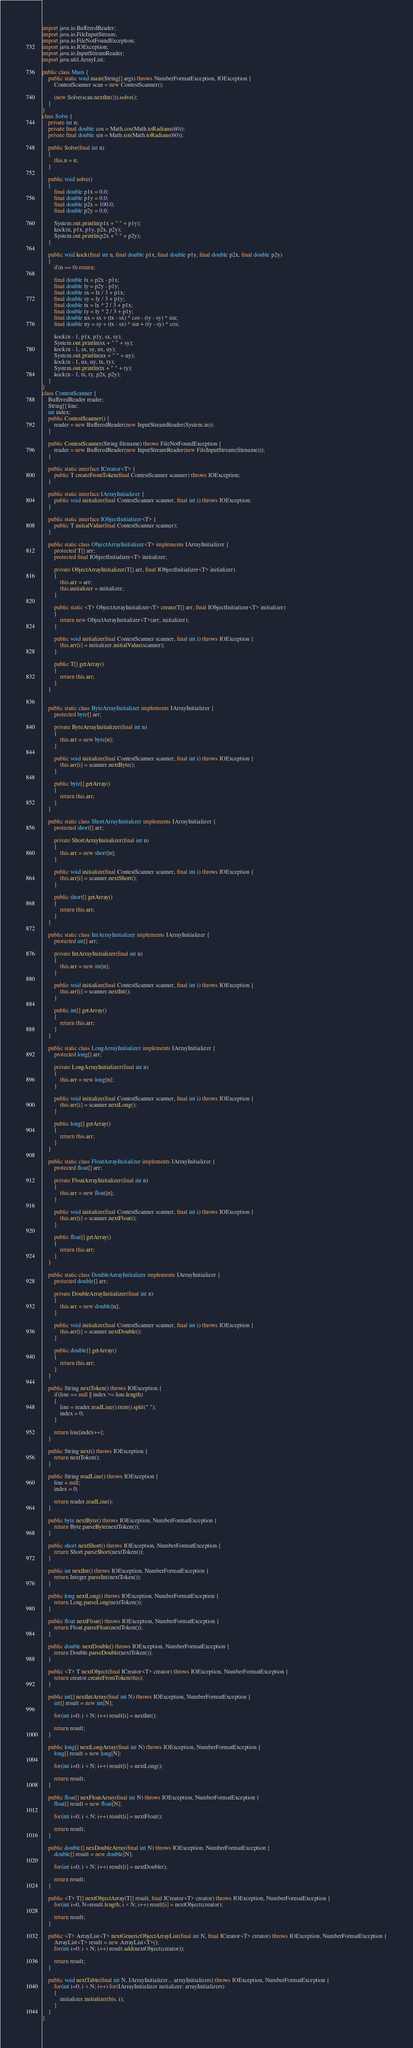Convert code to text. <code><loc_0><loc_0><loc_500><loc_500><_Java_>import java.io.BufferedReader;
import java.io.FileInputStream;
import java.io.FileNotFoundException;
import java.io.IOException;
import java.io.InputStreamReader;
import java.util.ArrayList;

public class Main {
	public static void main(String[] args) throws NumberFormatException, IOException {
		ContestScanner scan = new ContestScanner();

		(new Solve(scan.nextInt())).solve();
	}
}
class Solve {
	private int n;
	private final double cos = Math.cos(Math.toRadians(60));
	private final double sin = Math.sin(Math.toRadians(60));

	public Solve(final int n)
	{
		this.n = n;
	}

	public void solve()
	{
		final double p1x = 0.0;
		final double p1y = 0.0;
		final double p2x = 100.0;
		final double p2y = 0.0;

		System.out.println(p1x + " " + p1y);
		kock(n, p1x, p1y, p2x, p2y);
		System.out.println(p2x + " " + p2y);
	}

	public void kock(final int n, final double p1x, final double p1y, final double p2x, final double p2y)
	{
		if(n == 0) return;

		final double lx = p2x - p1x;
		final double ly = p2y - p1y;
		final double sx = lx / 3 + p1x;
		final double sy = ly / 3 + p1y;
		final double tx = lx * 2 / 3 + p1x;
		final double ty = ly * 2 / 3 + p1y;
		final double ux = sx + (tx - sx) * cos - (ty - sy) * sin;
		final double uy = sy + (tx - sx) * sin + (ty - sy) * cos;

		kock(n - 1, p1x, p1y, sx, sy);
		System.out.println(sx + " " + sy);
		kock(n - 1, sx, sy, ux, uy);
		System.out.println(ux + " " + uy);
		kock(n - 1, ux, uy, tx, ty);
		System.out.println(tx + " " + ty);
		kock(n - 1, tx, ty, p2x, p2y);
	}
}
class ContestScanner {
	BufferedReader reader;
	String[] line;
	int index;
	public ContestScanner() {
		reader = new BufferedReader(new InputStreamReader(System.in));
	}

	public ContestScanner(String filename) throws FileNotFoundException {
		reader = new BufferedReader(new InputStreamReader(new FileInputStream(filename)));
	}

	public static interface ICreator<T> {
		public T createFromToken(final ContestScanner scanner) throws IOException;
	}

	public static interface IArrayInitializer {
		public void initialize(final ContestScanner scanner, final int i) throws IOException;
	}

	public static interface IObjectInitializer<T> {
		public T initialValue(final ContestScanner scanner);
	}

	public static class ObjectArrayInitializer<T> implements IArrayInitializer {
		protected T[] arr;
		protected final IObjectInitializer<T> initializer;

		private ObjectArrayInitializer(T[] arr, final IObjectInitializer<T> initializer)
		{
			this.arr = arr;
			this.initializer = initializer;
		}

		public static <T> ObjectArrayInitializer<T> create(T[] arr, final IObjectInitializer<T> initializer)
		{
			return new ObjectArrayInitializer<T>(arr, initializer);
		}

		public void initialize(final ContestScanner scanner, final int i) throws IOException {
			this.arr[i] = initializer.initialValue(scanner);
		}

		public T[] getArray()
		{
			return this.arr;
		}
	}


	public static class ByteArrayInitializer implements IArrayInitializer {
		protected byte[] arr;

		private ByteArrayInitializer(final int n)
		{
			this.arr = new byte[n];
		}

		public void initialize(final ContestScanner scanner, final int i) throws IOException {
			this.arr[i] = scanner.nextByte();
		}

		public byte[] getArray()
		{
			return this.arr;
		}
	}

	public static class ShortArrayInitializer implements IArrayInitializer {
		protected short[] arr;

		private ShortArrayInitializer(final int n)
		{
			this.arr = new short[n];
		}

		public void initialize(final ContestScanner scanner, final int i) throws IOException {
			this.arr[i] = scanner.nextShort();
		}

		public short[] getArray()
		{
			return this.arr;
		}
	}

	public static class IntArrayInitializer implements IArrayInitializer {
		protected int[] arr;

		private IntArrayInitializer(final int n)
		{
			this.arr = new int[n];
		}

		public void initialize(final ContestScanner scanner, final int i) throws IOException {
			this.arr[i] = scanner.nextInt();
		}

		public int[] getArray()
		{
			return this.arr;
		}
	}

	public static class LongArrayInitializer implements IArrayInitializer {
		protected long[] arr;

		private LongArrayInitializer(final int n)
		{
			this.arr = new long[n];
		}

		public void initialize(final ContestScanner scanner, final int i) throws IOException {
			this.arr[i] = scanner.nextLong();
		}

		public long[] getArray()
		{
			return this.arr;
		}
	}

	public static class FloatArrayInitializer implements IArrayInitializer {
		protected float[] arr;

		private FloatArrayInitializer(final int n)
		{
			this.arr = new float[n];
		}

		public void initialize(final ContestScanner scanner, final int i) throws IOException {
			this.arr[i] = scanner.nextFloat();
		}

		public float[] getArray()
		{
			return this.arr;
		}
	}

	public static class DoubleArrayInitializer implements IArrayInitializer {
		protected double[] arr;

		private DoubleArrayInitializer(final int n)
		{
			this.arr = new double[n];
		}

		public void initialize(final ContestScanner scanner, final int i) throws IOException {
			this.arr[i] = scanner.nextDouble();
		}

		public double[] getArray()
		{
			return this.arr;
		}
	}

	public String nextToken() throws IOException {
		if(line == null || index >= line.length)
		{
			line = reader.readLine().trim().split(" ");
			index = 0;
		}

		return line[index++];
	}

	public String next() throws IOException {
		return nextToken();
	}

	public String readLine() throws IOException {
		line = null;
		index = 0;

		return reader.readLine();
	}

	public byte nextByte() throws IOException, NumberFormatException {
		return Byte.parseByte(nextToken());
	}

	public short nextShort() throws IOException, NumberFormatException {
		return Short.parseShort(nextToken());
	}

	public int nextInt() throws IOException, NumberFormatException {
		return Integer.parseInt(nextToken());
	}

	public long nextLong() throws IOException, NumberFormatException {
		return Long.parseLong(nextToken());
	}

	public float nextFloat() throws IOException, NumberFormatException {
		return Float.parseFloat(nextToken());
	}

	public double nextDouble() throws IOException, NumberFormatException {
		return Double.parseDouble(nextToken());
	}

	public <T> T nextObject(final ICreator<T> creator) throws IOException, NumberFormatException {
		return creator.createFromToken(this);
	}

	public int[] nextIntArray(final int N) throws IOException, NumberFormatException {
		int[] result = new int[N];

		for(int i=0; i < N; i++) result[i] = nextInt();

		return result;
	}

	public long[] nextLongArray(final int N) throws IOException, NumberFormatException {
		long[] result = new long[N];

		for(int i=0; i < N; i++) result[i] = nextLong();

		return result;
	}

	public float[] nexFloatArray(final int N) throws IOException, NumberFormatException {
		float[] result = new float[N];

		for(int i=0; i < N; i++) result[i] = nextFloat();

		return result;
	}

	public double[] nexDoubleArray(final int N) throws IOException, NumberFormatException {
		double[] result = new double[N];

		for(int i=0; i < N; i++) result[i] = nextDouble();

		return result;
	}

	public <T> T[] nextObjectArray(T[] result, final ICreator<T> creator) throws IOException, NumberFormatException {
		for(int i=0, N=result.length; i < N; i++) result[i] = nextObject(creator);

		return result;
	}

	public <T> ArrayList<T> nextGenericObjectArrayList(final int N, final ICreator<T> creator) throws IOException, NumberFormatException {
		ArrayList<T> result = new ArrayList<T>();
		for(int i=0; i < N; i++) result.add(nextObject(creator));

		return result;
	}

	public void nextTable(final int N, IArrayInitializer... arrayInitializers) throws IOException, NumberFormatException {
		for(int i=0; i < N; i++) for(IArrayInitializer initializer: arrayInitializers)
		{
			initializer.initialize(this, i);
		}
	}
}</code> 